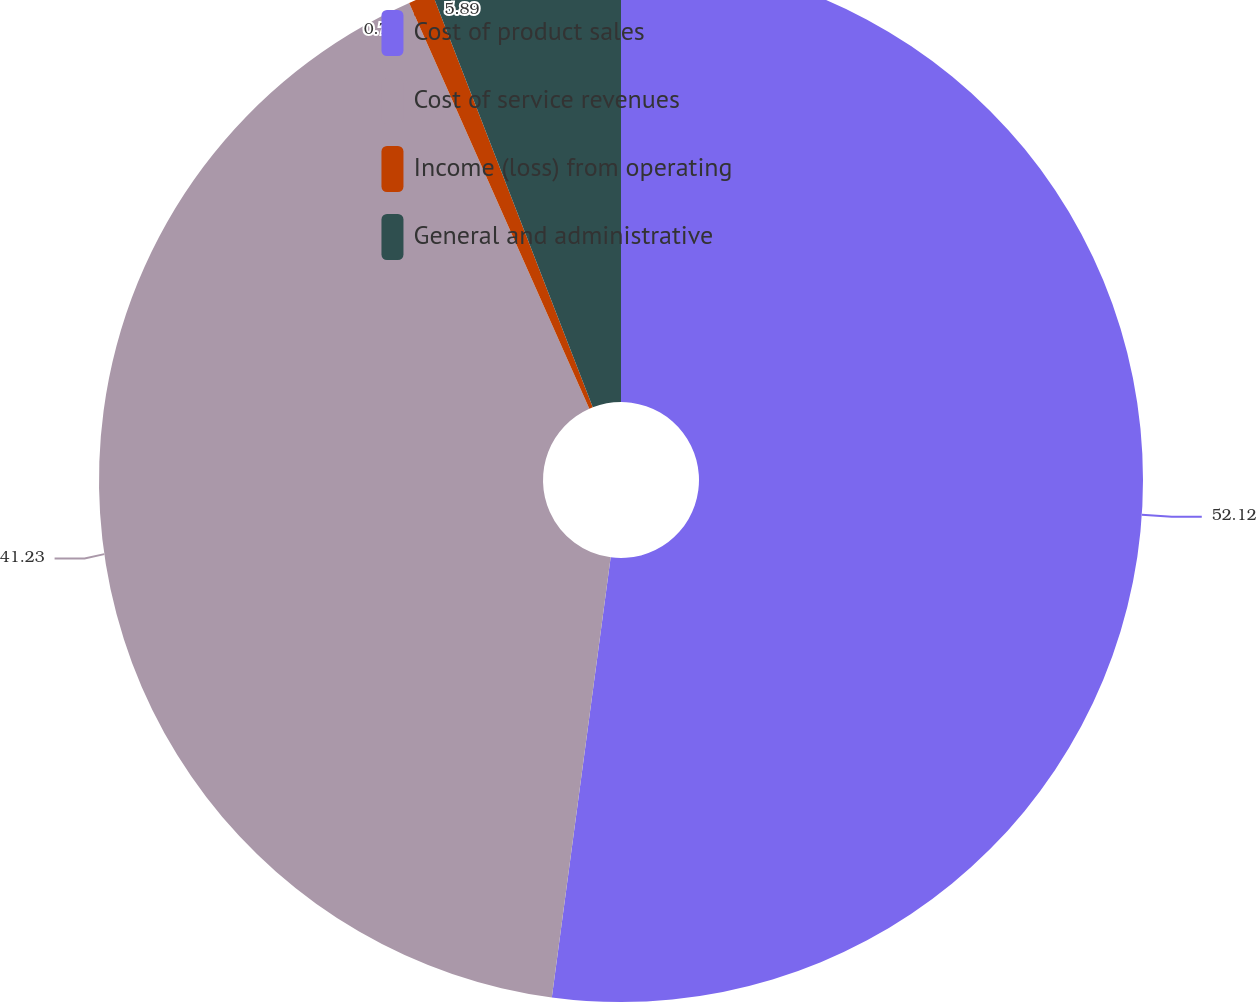<chart> <loc_0><loc_0><loc_500><loc_500><pie_chart><fcel>Cost of product sales<fcel>Cost of service revenues<fcel>Income (loss) from operating<fcel>General and administrative<nl><fcel>52.11%<fcel>41.23%<fcel>0.76%<fcel>5.89%<nl></chart> 